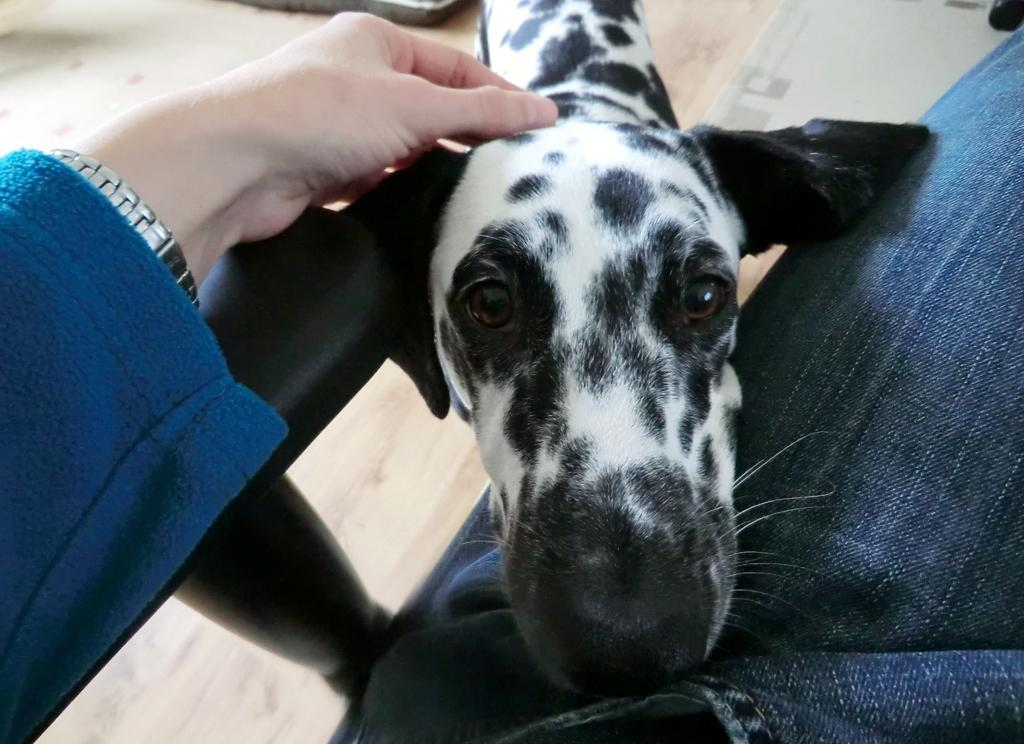What is happening in the image involving a person and a dog? In the image, a person is placing a hand on a dog. Where is the dog located in the image? The dog is on the floor. What type of ring can be seen on the dog's paw in the image? There is no ring present on the dog's paw in the image. 